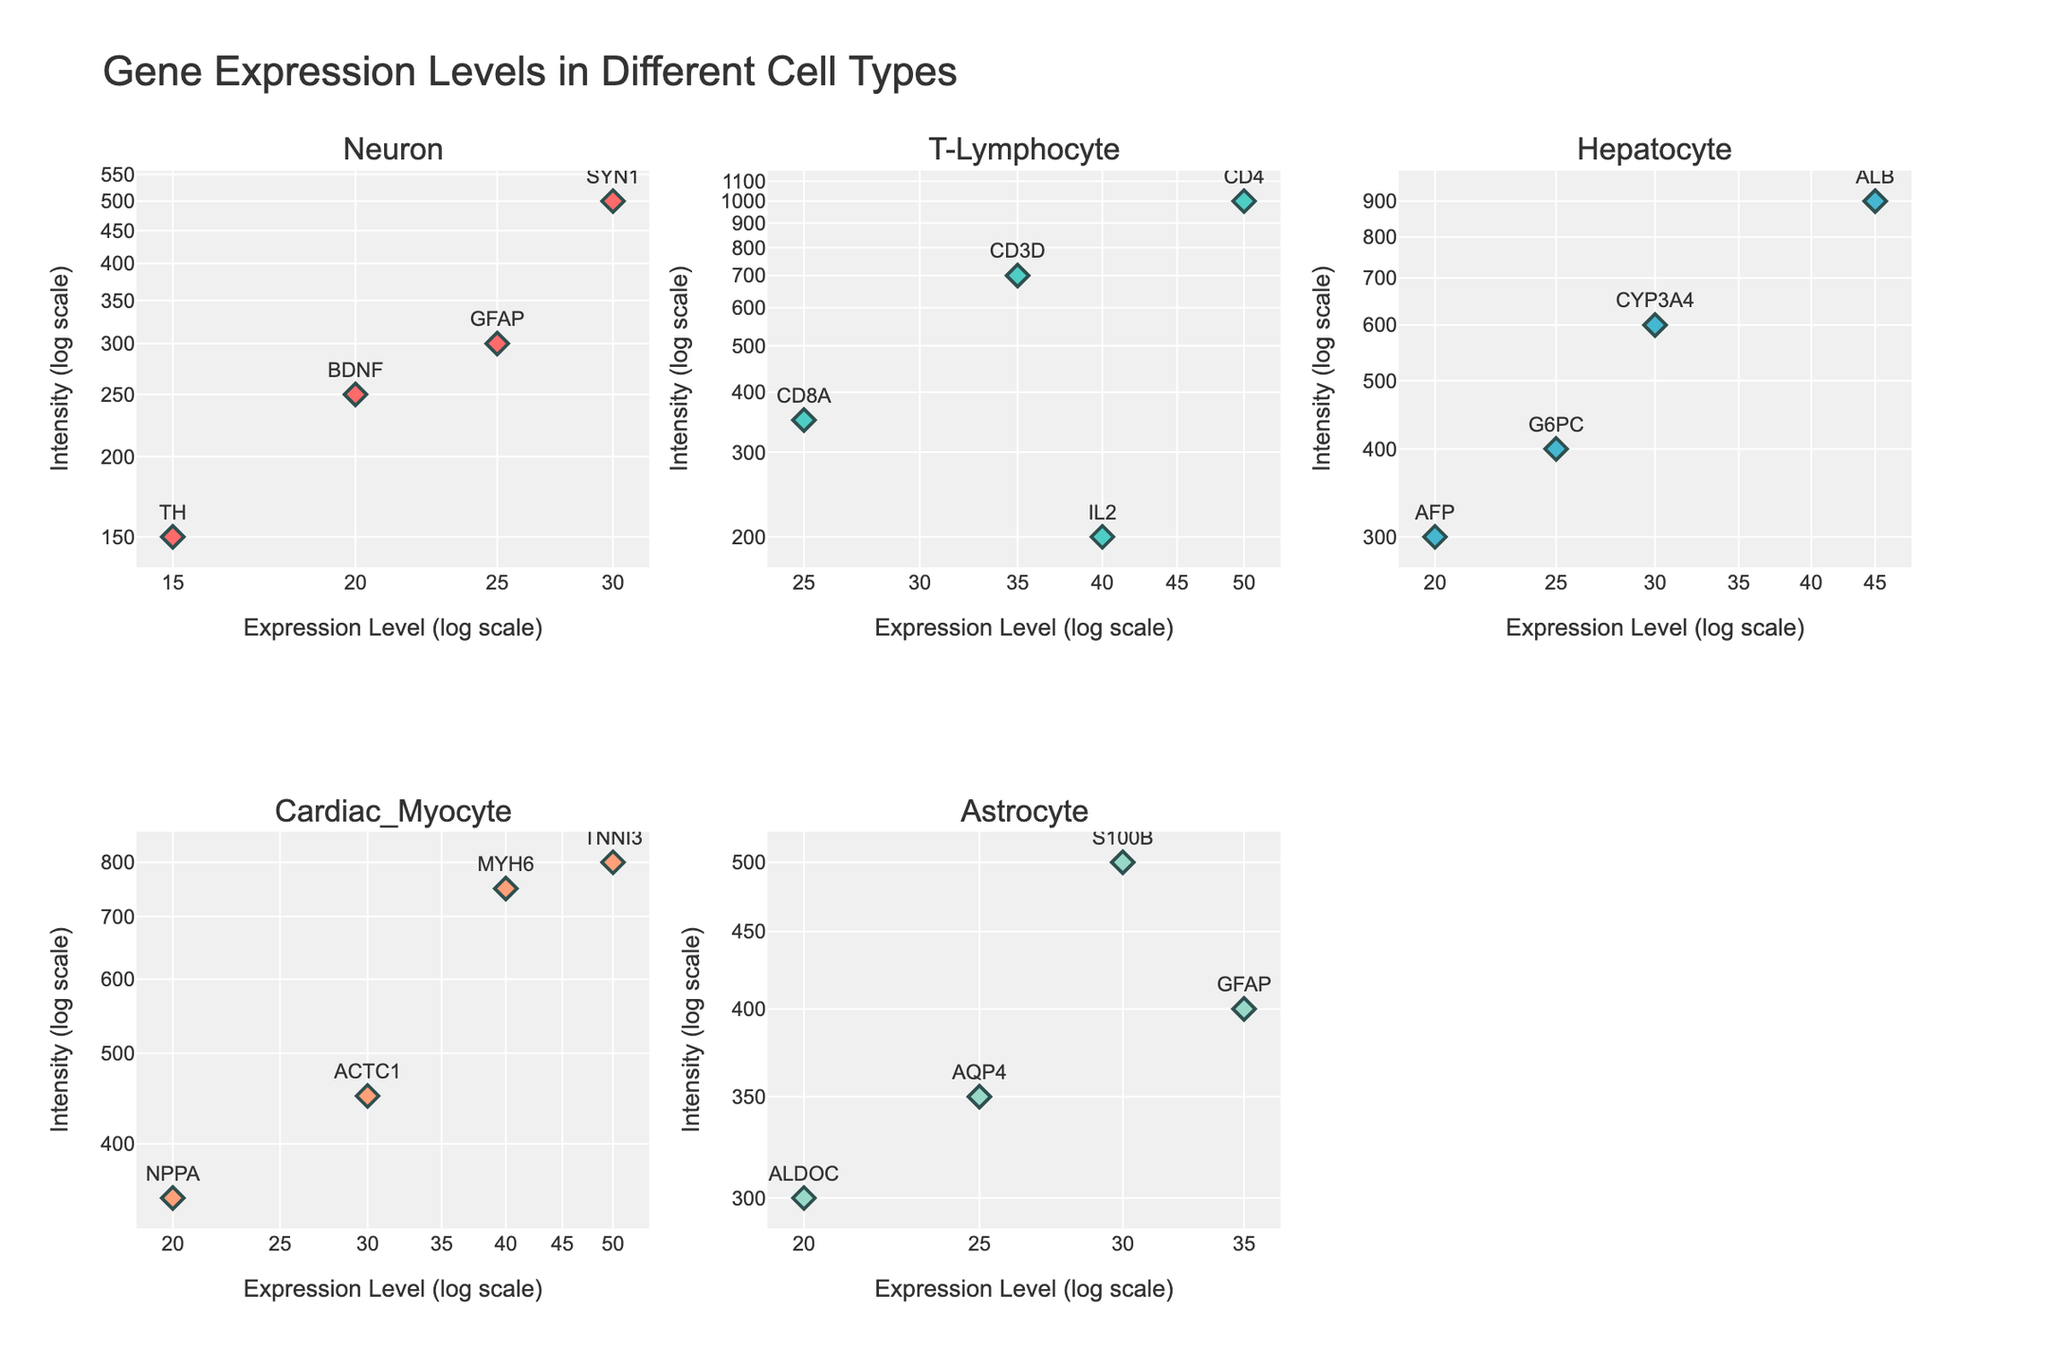Which cell type shows the highest intensity value for gene expression? By scanning the scatter plots across all subplots, T-Lymphocyte, with CD4 gene, shows the highest intensity of 1000.
Answer: T-Lymphocyte In the Neuron cell type, which gene has the lowest expression level? Focusing on the Neuron subplot, the gene TH has the lowest expression level at 15.
Answer: TH Between Astrocyte and Neuron cell types, which gene has a higher expression level but lower intensity? In the Neuron cell type, GFAP has an expression level of 25 and intensity of 300. In the Astrocyte cell type, ALDOC has the same expression level but a lower intensity of 300. Thus, GFAP (Neuron) has a higher expression level but lower intensity.
Answer: GFAP What is the average intensity value for the genes in Hepatocytes? Intensity values for Hepatocytes are 900, 600, 300, and 400. Sum these values: 900 + 600 + 300 + 400 = 2200. Calculate the average: 2200 / 4 = 550.
Answer: 550 Which cell type has the gene with the highest expression level, and what is this level? Scanning all subplots, the highest expression level is observed in T-Lymphocytes for the gene CD4, which is 50.
Answer: T-Lymphocyte, 50 How many genes have both expression levels and intensities greater than 30 in the figure? Looking at all subplots, the genes SYN1 (Neuron), CD4 (T-Lymphocyte), ALB (Hepatocyte), and TNNI3 (Cardiac Myocyte) satisfy both conditions. Therefore, 4 genes meet the criteria.
Answer: 4 In T-Lymphocytes, which gene has the closest intensity value to 500? In T-Lymphocytes, the gene CD8A has an intensity of 350, which is the closest value to 500.
Answer: CD8A Which cell type shows the most overall spread in its gene expression levels? Comparing the range of expression levels in each subplot: 
- Neuron: 15 to 30 (15)
- T-Lymphocyte: 25 to 50 (25)
- Hepatocyte: 20 to 45 (25)
- Cardiac Myocyte: 20 to 50 (30)
- Astrocyte: 20 to 35 (15)
The Cardiac Myocyte has the greatest spread, from 20 to 50, a range of 30.
Answer: Cardiac Myocyte 